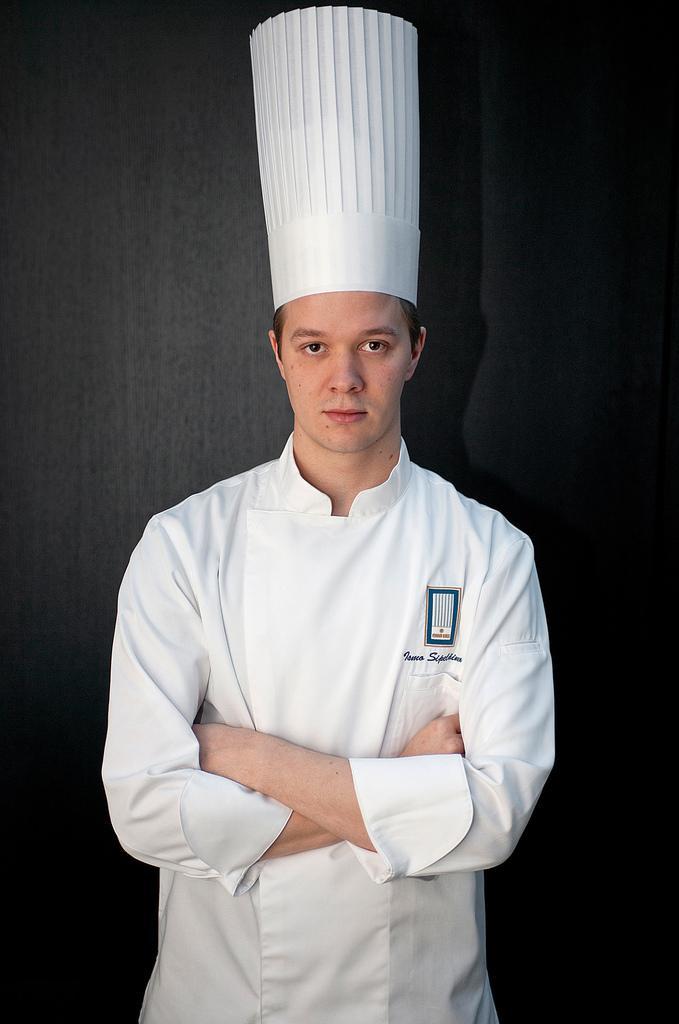Please provide a concise description of this image. In this image I can see a man is standing in the front. I can see he is wearing chef dress and a chef hat. I can also see black colour wall in the background. 